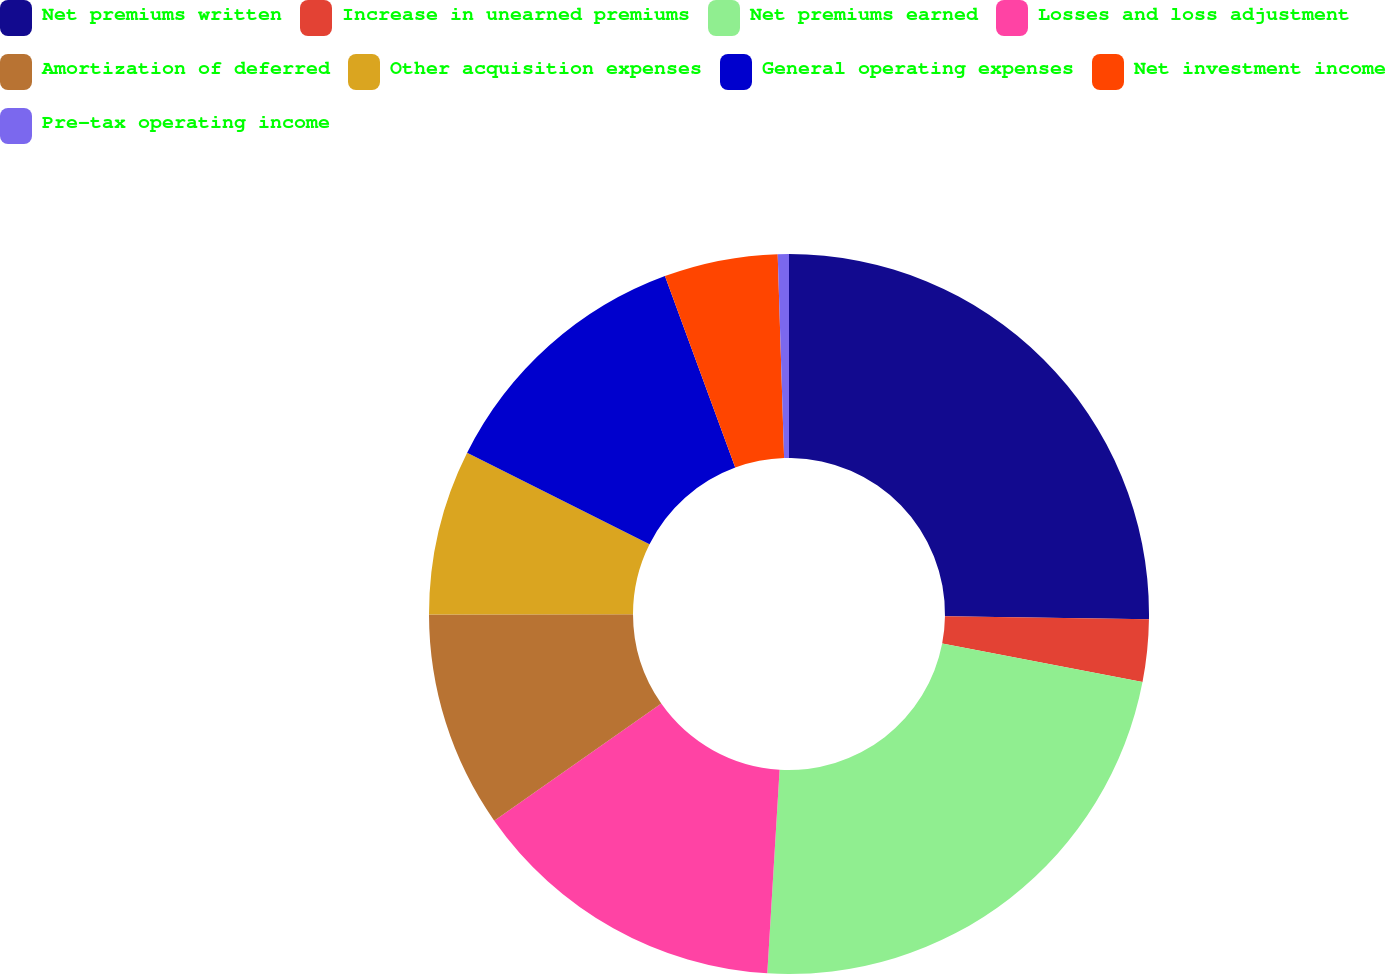Convert chart to OTSL. <chart><loc_0><loc_0><loc_500><loc_500><pie_chart><fcel>Net premiums written<fcel>Increase in unearned premiums<fcel>Net premiums earned<fcel>Losses and loss adjustment<fcel>Amortization of deferred<fcel>Other acquisition expenses<fcel>General operating expenses<fcel>Net investment income<fcel>Pre-tax operating income<nl><fcel>25.23%<fcel>2.8%<fcel>22.93%<fcel>14.31%<fcel>9.71%<fcel>7.41%<fcel>12.01%<fcel>5.1%<fcel>0.5%<nl></chart> 